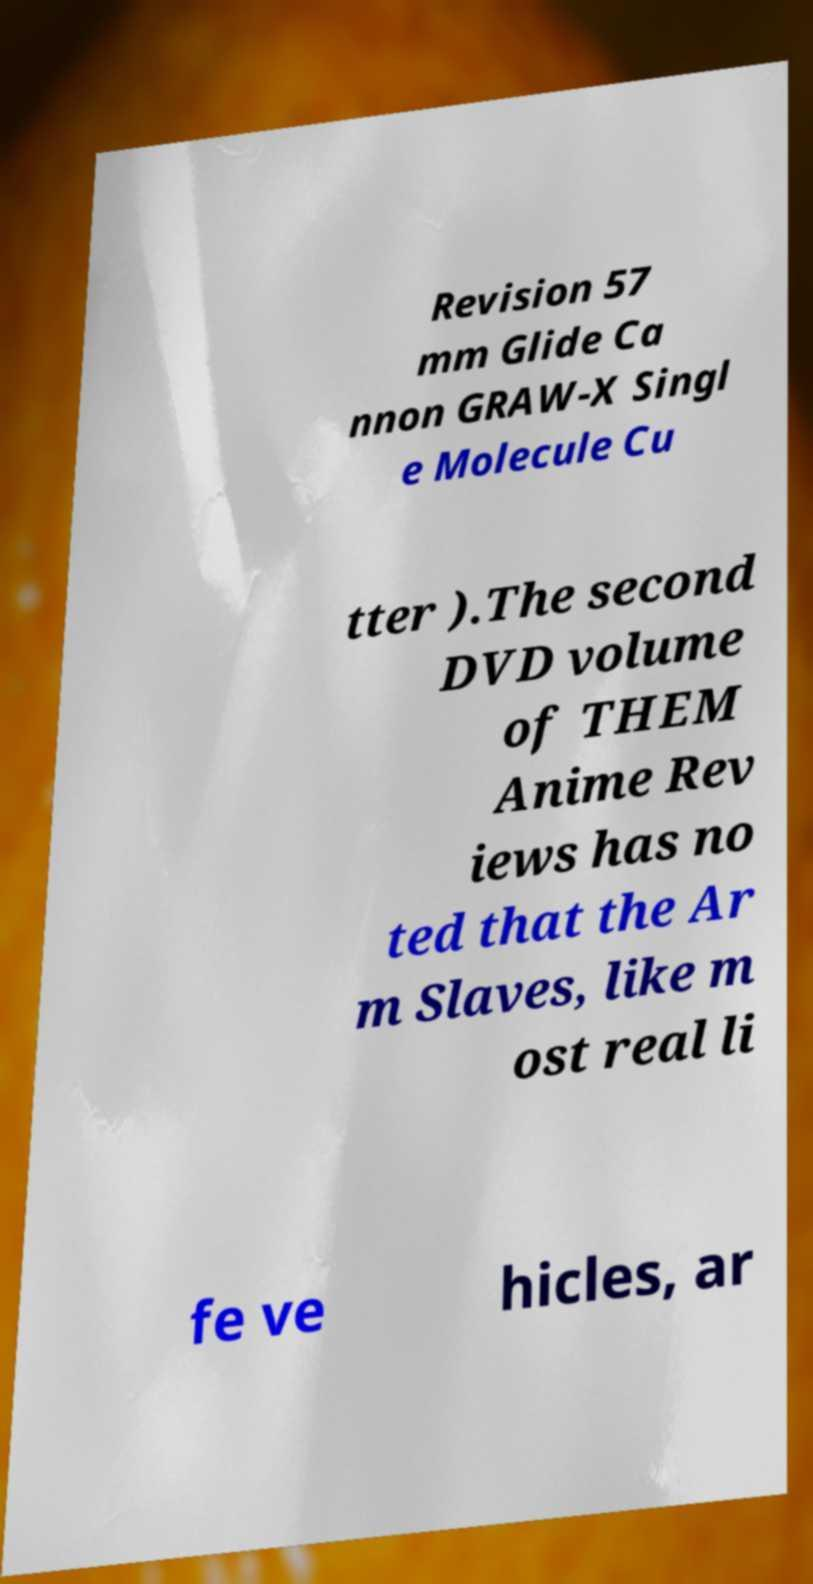There's text embedded in this image that I need extracted. Can you transcribe it verbatim? Revision 57 mm Glide Ca nnon GRAW-X Singl e Molecule Cu tter ).The second DVD volume of THEM Anime Rev iews has no ted that the Ar m Slaves, like m ost real li fe ve hicles, ar 